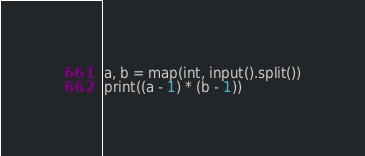<code> <loc_0><loc_0><loc_500><loc_500><_Python_>a, b = map(int, input().split())
print((a - 1) * (b - 1))</code> 